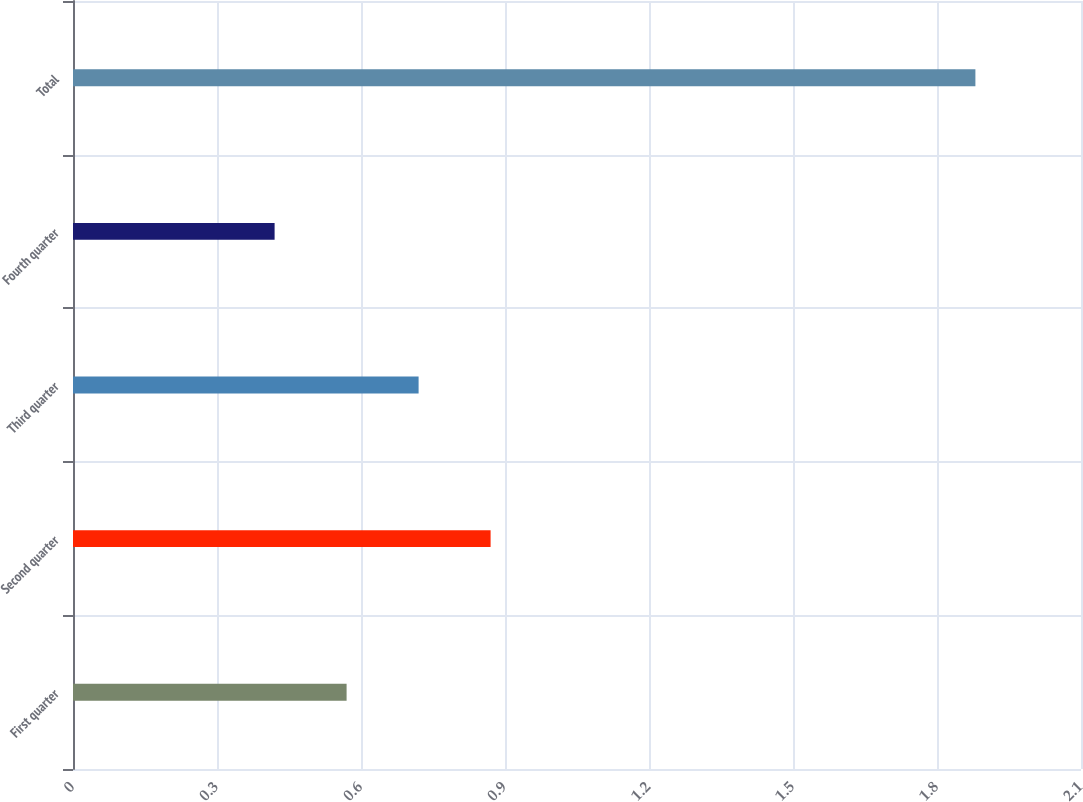Convert chart to OTSL. <chart><loc_0><loc_0><loc_500><loc_500><bar_chart><fcel>First quarter<fcel>Second quarter<fcel>Third quarter<fcel>Fourth quarter<fcel>Total<nl><fcel>0.57<fcel>0.87<fcel>0.72<fcel>0.42<fcel>1.88<nl></chart> 